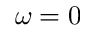<formula> <loc_0><loc_0><loc_500><loc_500>\omega = 0</formula> 